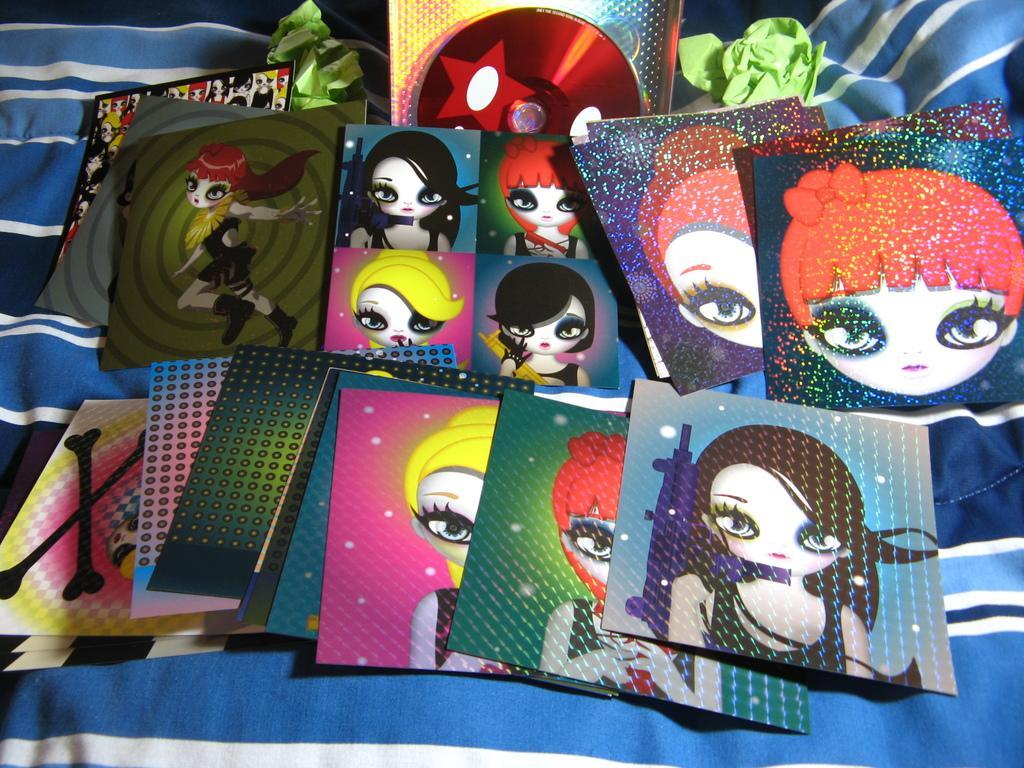Could you give a brief overview of what you see in this image? In this image there are graphic images on the cards and there are some objects on the cloth. 